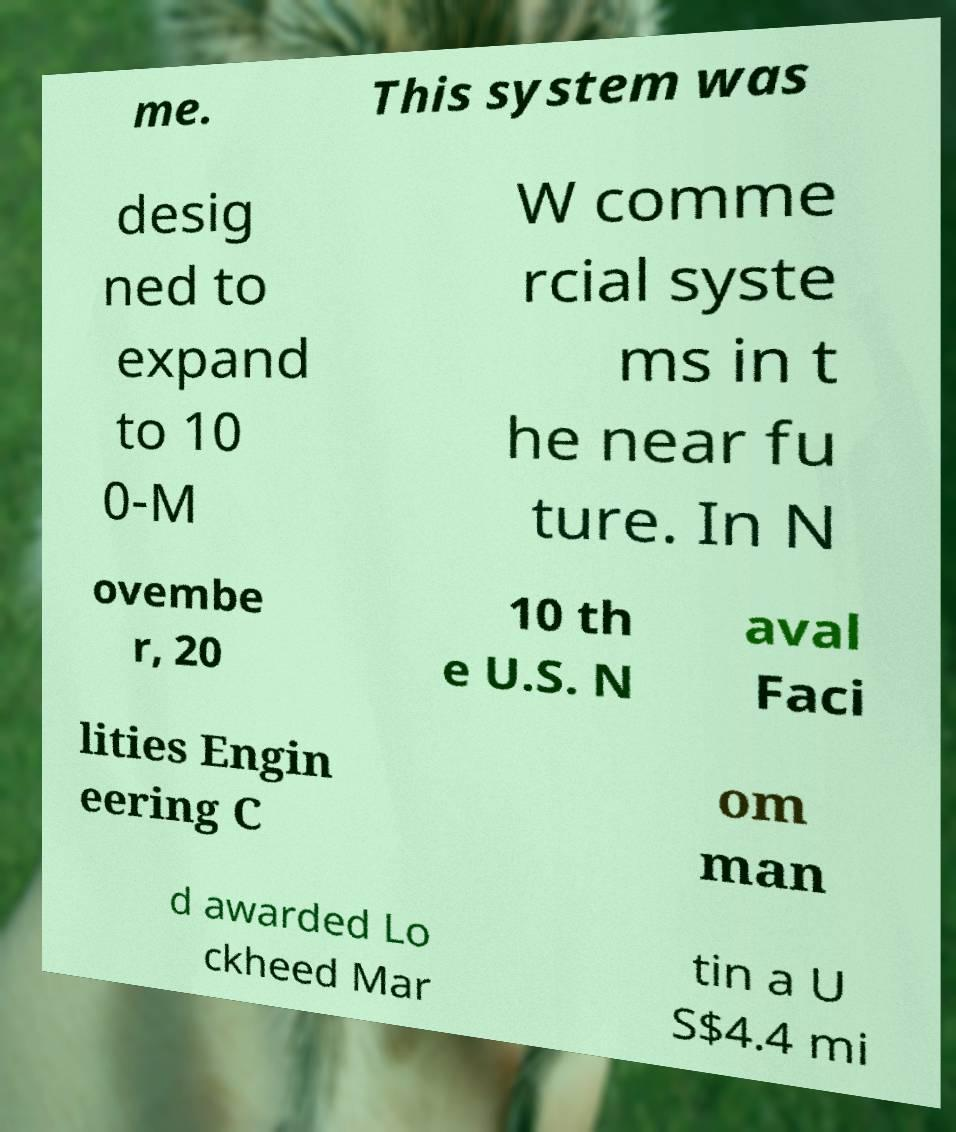What messages or text are displayed in this image? I need them in a readable, typed format. me. This system was desig ned to expand to 10 0-M W comme rcial syste ms in t he near fu ture. In N ovembe r, 20 10 th e U.S. N aval Faci lities Engin eering C om man d awarded Lo ckheed Mar tin a U S$4.4 mi 